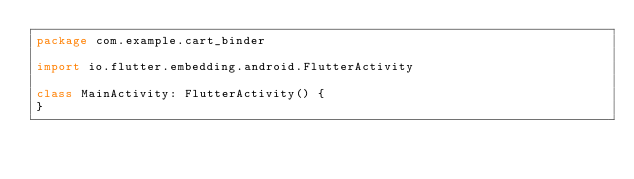Convert code to text. <code><loc_0><loc_0><loc_500><loc_500><_Kotlin_>package com.example.cart_binder

import io.flutter.embedding.android.FlutterActivity

class MainActivity: FlutterActivity() {
}
</code> 